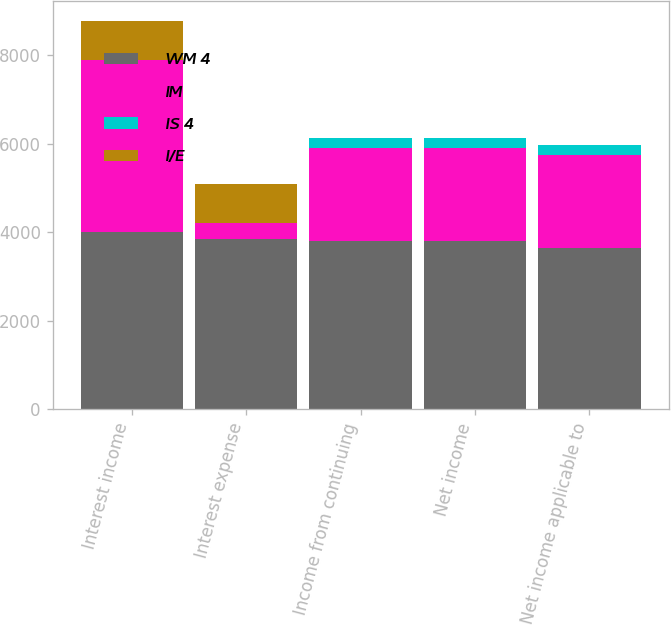Convert chart to OTSL. <chart><loc_0><loc_0><loc_500><loc_500><stacked_bar_chart><ecel><fcel>Interest income<fcel>Interest expense<fcel>Income from continuing<fcel>Net income<fcel>Net income applicable to<nl><fcel>WM 4<fcel>4005<fcel>3840<fcel>3805<fcel>3804<fcel>3649<nl><fcel>IM<fcel>3888<fcel>359<fcel>2104<fcel>2104<fcel>2104<nl><fcel>IS 4<fcel>5<fcel>1<fcel>212<fcel>214<fcel>225<nl><fcel>I/E<fcel>882<fcel>882<fcel>1<fcel>1<fcel>1<nl></chart> 